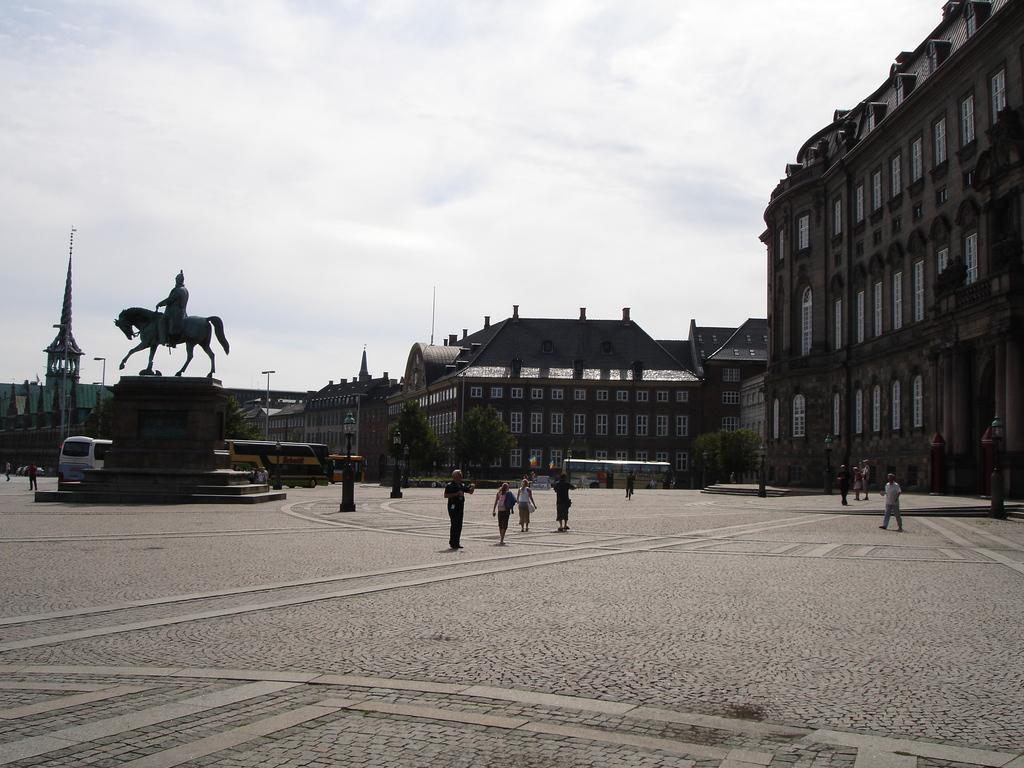Describe this image in one or two sentences. In this image I can see on the left side there is a statue of a man on a horse. In the middle few people are walking. On the back side there are trees and buildings and there are buses. At the top it is the cloudy sky. 